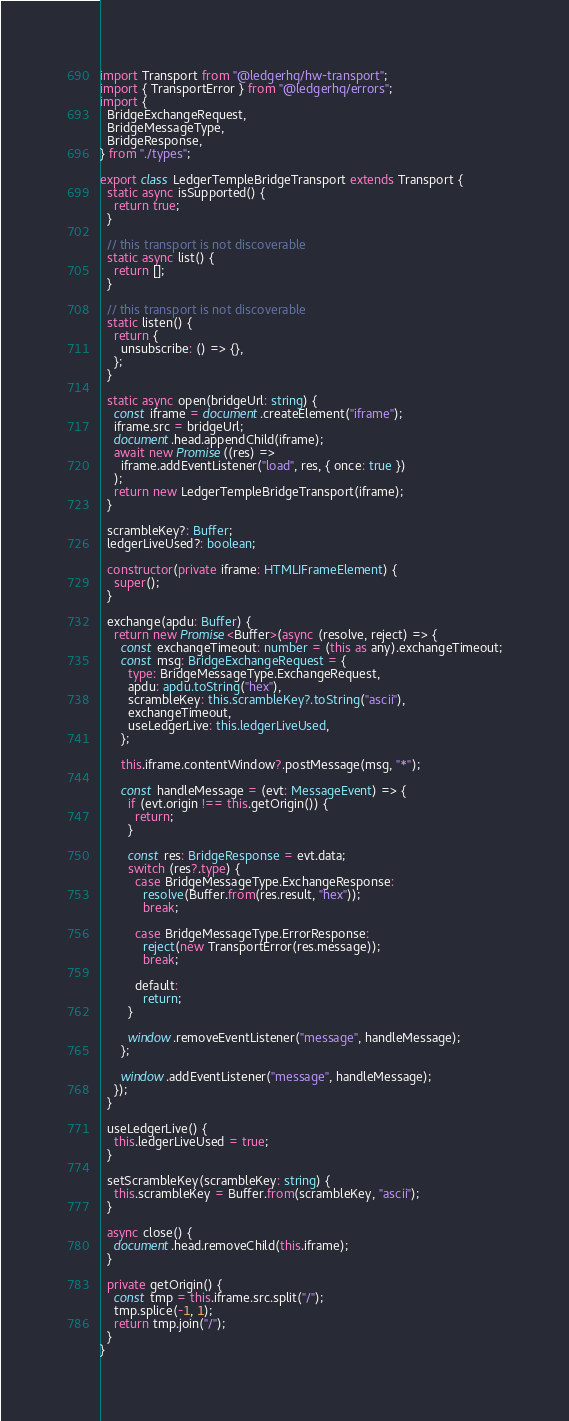Convert code to text. <code><loc_0><loc_0><loc_500><loc_500><_TypeScript_>import Transport from "@ledgerhq/hw-transport";
import { TransportError } from "@ledgerhq/errors";
import {
  BridgeExchangeRequest,
  BridgeMessageType,
  BridgeResponse,
} from "./types";

export class LedgerTempleBridgeTransport extends Transport {
  static async isSupported() {
    return true;
  }

  // this transport is not discoverable
  static async list() {
    return [];
  }

  // this transport is not discoverable
  static listen() {
    return {
      unsubscribe: () => {},
    };
  }

  static async open(bridgeUrl: string) {
    const iframe = document.createElement("iframe");
    iframe.src = bridgeUrl;
    document.head.appendChild(iframe);
    await new Promise((res) =>
      iframe.addEventListener("load", res, { once: true })
    );
    return new LedgerTempleBridgeTransport(iframe);
  }

  scrambleKey?: Buffer;
  ledgerLiveUsed?: boolean;

  constructor(private iframe: HTMLIFrameElement) {
    super();
  }

  exchange(apdu: Buffer) {
    return new Promise<Buffer>(async (resolve, reject) => {
      const exchangeTimeout: number = (this as any).exchangeTimeout;
      const msg: BridgeExchangeRequest = {
        type: BridgeMessageType.ExchangeRequest,
        apdu: apdu.toString("hex"),
        scrambleKey: this.scrambleKey?.toString("ascii"),
        exchangeTimeout,
        useLedgerLive: this.ledgerLiveUsed,
      };

      this.iframe.contentWindow?.postMessage(msg, "*");

      const handleMessage = (evt: MessageEvent) => {
        if (evt.origin !== this.getOrigin()) {
          return;
        }

        const res: BridgeResponse = evt.data;
        switch (res?.type) {
          case BridgeMessageType.ExchangeResponse:
            resolve(Buffer.from(res.result, "hex"));
            break;

          case BridgeMessageType.ErrorResponse:
            reject(new TransportError(res.message));
            break;

          default:
            return;
        }

        window.removeEventListener("message", handleMessage);
      };

      window.addEventListener("message", handleMessage);
    });
  }

  useLedgerLive() {
    this.ledgerLiveUsed = true;
  }

  setScrambleKey(scrambleKey: string) {
    this.scrambleKey = Buffer.from(scrambleKey, "ascii");
  }

  async close() {
    document.head.removeChild(this.iframe);
  }

  private getOrigin() {
    const tmp = this.iframe.src.split("/");
    tmp.splice(-1, 1);
    return tmp.join("/");
  }
}
</code> 